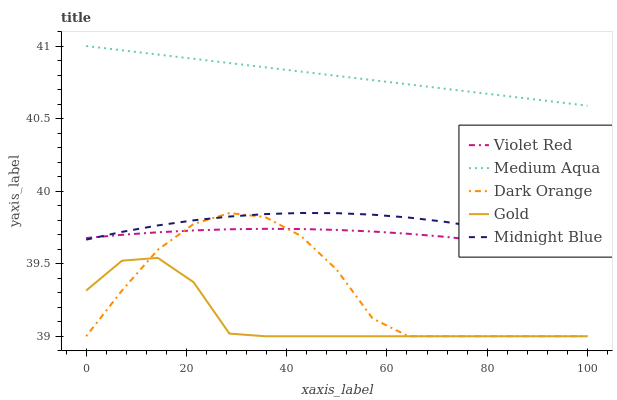Does Gold have the minimum area under the curve?
Answer yes or no. Yes. Does Medium Aqua have the maximum area under the curve?
Answer yes or no. Yes. Does Violet Red have the minimum area under the curve?
Answer yes or no. No. Does Violet Red have the maximum area under the curve?
Answer yes or no. No. Is Medium Aqua the smoothest?
Answer yes or no. Yes. Is Dark Orange the roughest?
Answer yes or no. Yes. Is Violet Red the smoothest?
Answer yes or no. No. Is Violet Red the roughest?
Answer yes or no. No. Does Violet Red have the lowest value?
Answer yes or no. No. Does Medium Aqua have the highest value?
Answer yes or no. Yes. Does Violet Red have the highest value?
Answer yes or no. No. Is Midnight Blue less than Medium Aqua?
Answer yes or no. Yes. Is Midnight Blue greater than Gold?
Answer yes or no. Yes. Does Violet Red intersect Midnight Blue?
Answer yes or no. Yes. Is Violet Red less than Midnight Blue?
Answer yes or no. No. Is Violet Red greater than Midnight Blue?
Answer yes or no. No. Does Midnight Blue intersect Medium Aqua?
Answer yes or no. No. 